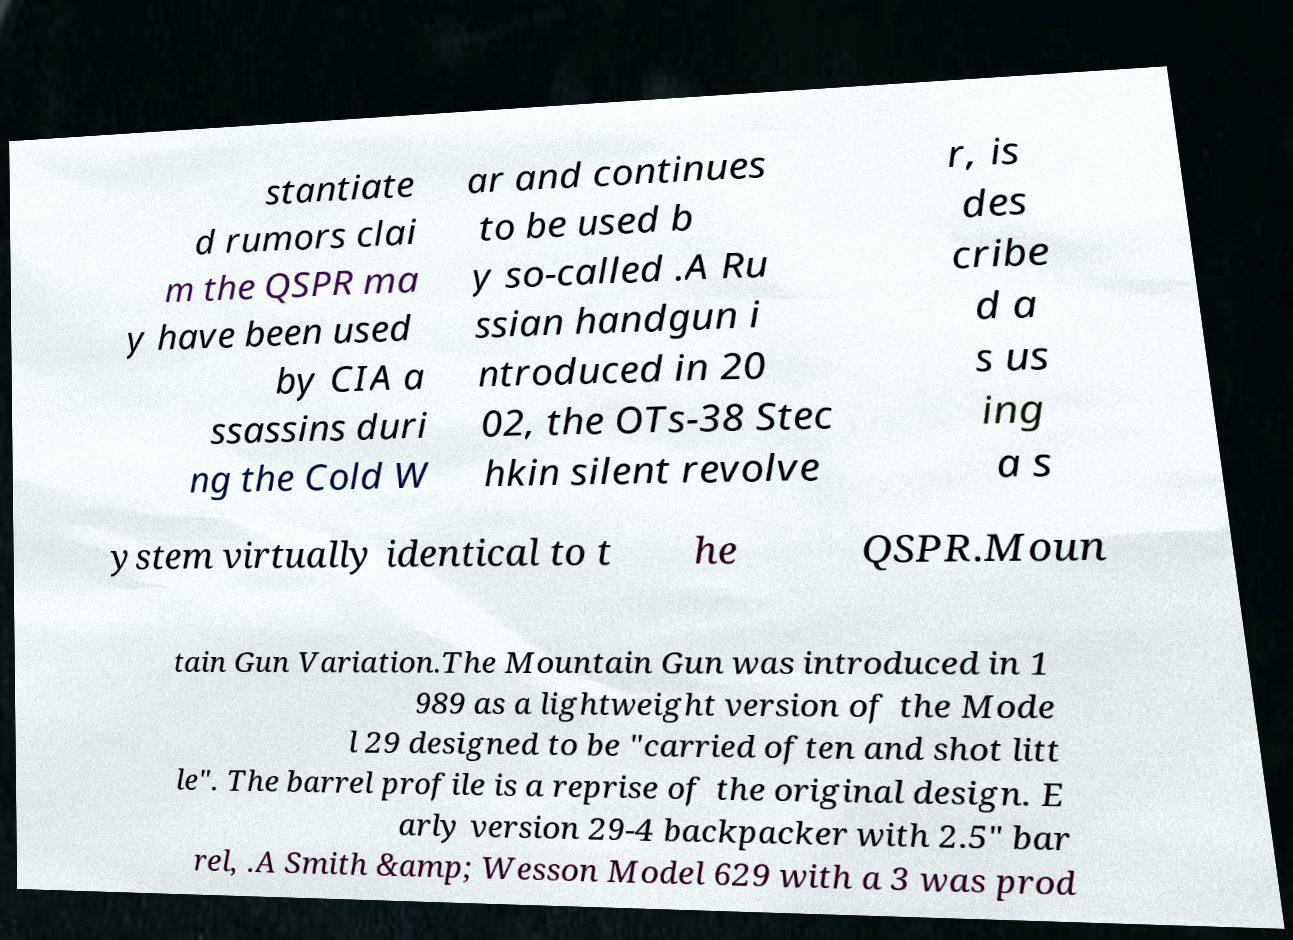Could you extract and type out the text from this image? stantiate d rumors clai m the QSPR ma y have been used by CIA a ssassins duri ng the Cold W ar and continues to be used b y so-called .A Ru ssian handgun i ntroduced in 20 02, the OTs-38 Stec hkin silent revolve r, is des cribe d a s us ing a s ystem virtually identical to t he QSPR.Moun tain Gun Variation.The Mountain Gun was introduced in 1 989 as a lightweight version of the Mode l 29 designed to be "carried often and shot litt le". The barrel profile is a reprise of the original design. E arly version 29-4 backpacker with 2.5" bar rel, .A Smith &amp; Wesson Model 629 with a 3 was prod 